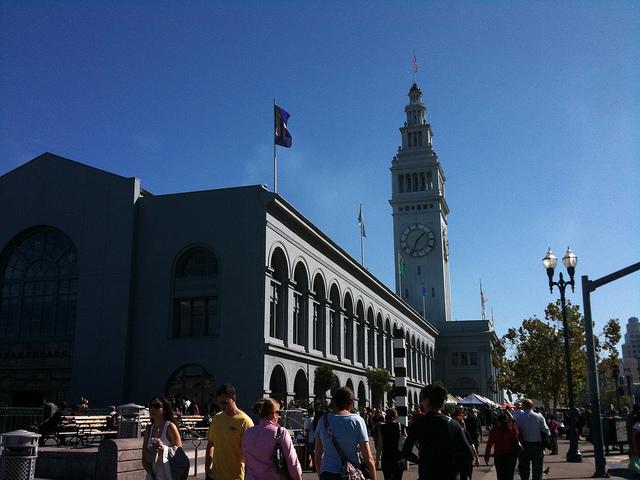What are the objects flying in the sky?
Quick response, please. Flags. What season is it in the picture?
Be succinct. Summer. How many women are wearing pink shirts?
Be succinct. 1. Is this a church?
Give a very brief answer. No. What are the weather conditions?
Keep it brief. Clear. What color is the building?
Answer briefly. White. How many street lights are visible on the light pole on the right?
Be succinct. 2. Is the sun out in this picture?
Quick response, please. Yes. How many people are in the picture?
Be succinct. 25. What state flag is this?
Concise answer only. Unknown. Are the people exploring the city?
Concise answer only. Yes. How many females are in this picture?
Write a very short answer. 4. What color is the street light?
Keep it brief. Black. Is that the Big Ben clock tower in the background?
Be succinct. No. What is in the sky?
Answer briefly. Flag. What color is the flag on the left?
Answer briefly. Blue. 